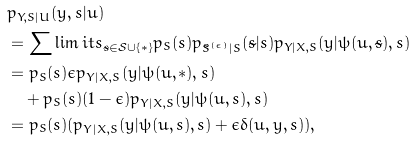Convert formula to latex. <formula><loc_0><loc_0><loc_500><loc_500>& p _ { Y , S | U } ( y , s | u ) \\ & = \sum \lim i t s _ { \tilde { s } \in \mathcal { S } \cup \{ \ast \} } p _ { S } ( s ) p _ { \tilde { S } ^ { ( \epsilon ) } | S } ( \tilde { s } | s ) p _ { Y | X , S } ( y | \psi ( u , \tilde { s } ) , s ) \\ & = p _ { S } ( s ) \epsilon p _ { Y | X , S } ( y | \psi ( u , \ast ) , s ) \\ & \quad + p _ { S } ( s ) ( 1 - \epsilon ) p _ { Y | X , S } ( y | \psi ( u , s ) , s ) \\ & = p _ { S } ( s ) ( p _ { Y | X , S } ( y | \psi ( u , s ) , s ) + \epsilon \delta ( u , y , s ) ) ,</formula> 